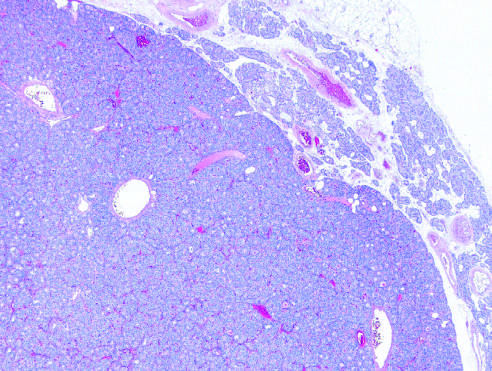what is delineated from the residual normocellular gland on the upper right in this low-power view?
Answer the question using a single word or phrase. A solitary hypercellular adenoma 